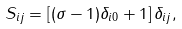Convert formula to latex. <formula><loc_0><loc_0><loc_500><loc_500>S _ { i j } = \left [ ( \sigma - 1 ) \delta _ { i 0 } + 1 \right ] \delta _ { i j } ,</formula> 